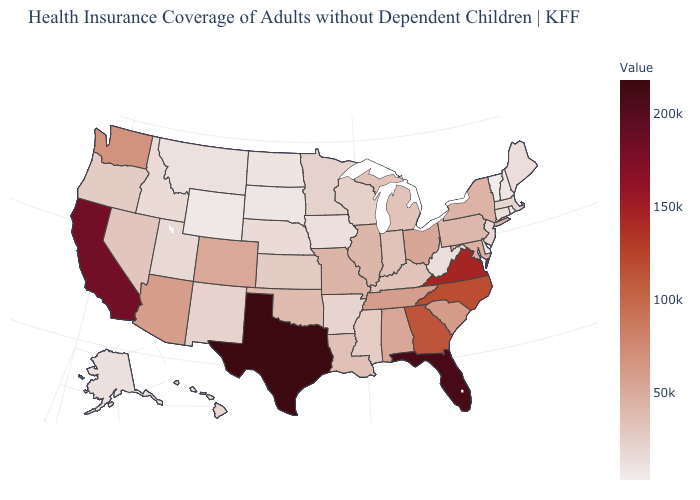Is the legend a continuous bar?
Answer briefly. Yes. Among the states that border Oregon , which have the lowest value?
Concise answer only. Idaho. Which states have the lowest value in the Northeast?
Short answer required. Vermont. Which states have the lowest value in the USA?
Give a very brief answer. Vermont. 